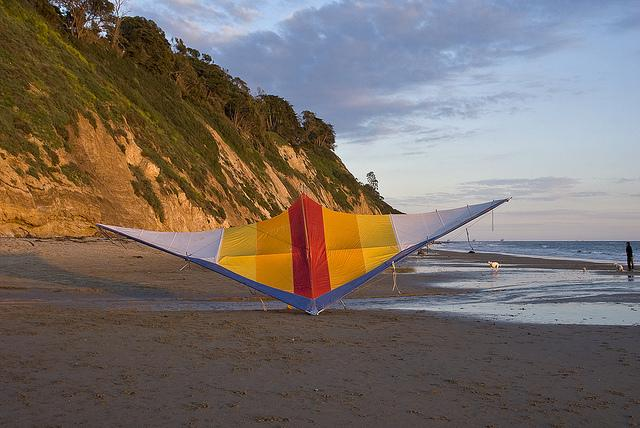What color is in the middle of the kite? red 